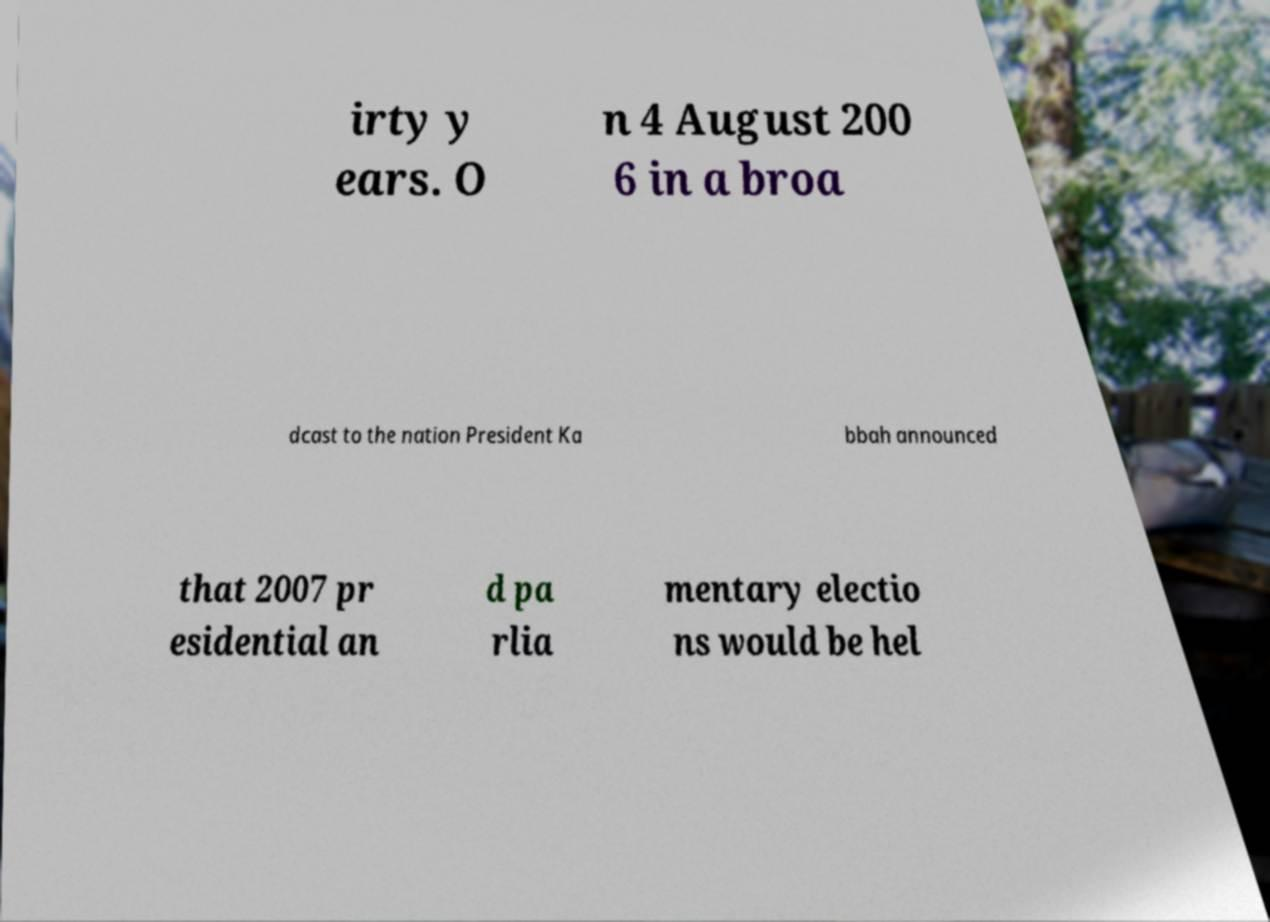There's text embedded in this image that I need extracted. Can you transcribe it verbatim? irty y ears. O n 4 August 200 6 in a broa dcast to the nation President Ka bbah announced that 2007 pr esidential an d pa rlia mentary electio ns would be hel 